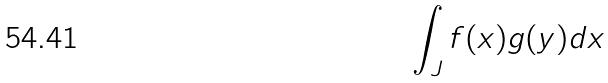Convert formula to latex. <formula><loc_0><loc_0><loc_500><loc_500>\int _ { J } f ( x ) g ( y ) d x</formula> 